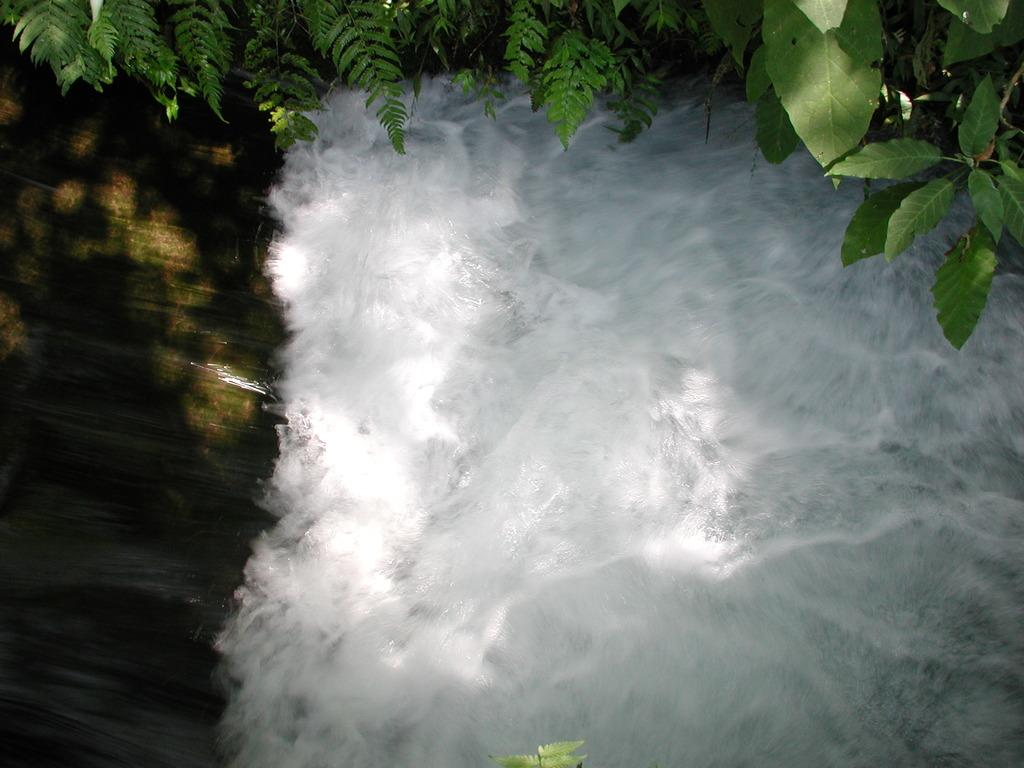What is happening in the image? There is water flowing in the image. What can be seen in the background of the image? There are trees in the image. How does the harbor support the trees in the image? There is no harbor present in the image, and therefore it cannot support any trees. 